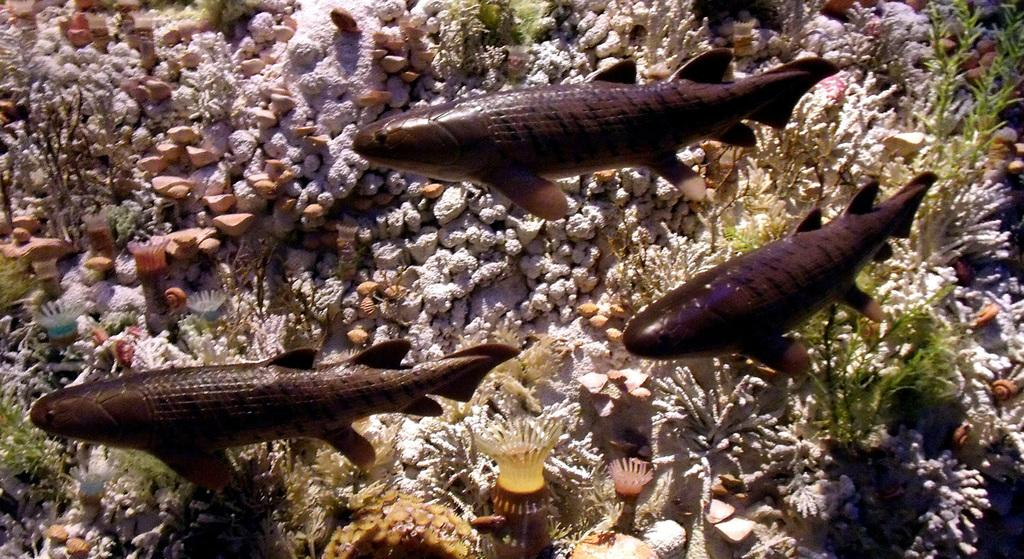What type of animals can be seen in the image? There are fishes in the water in the image. What else can be seen in the image besides the fishes? There are stones visible in the image. What type of shop can be seen in the image? There is no shop present in the image; it features fishes in the water and stones. What kind of drug is being exchanged in the image? There is no exchange of drugs or any indication of drug-related activity in the image. 